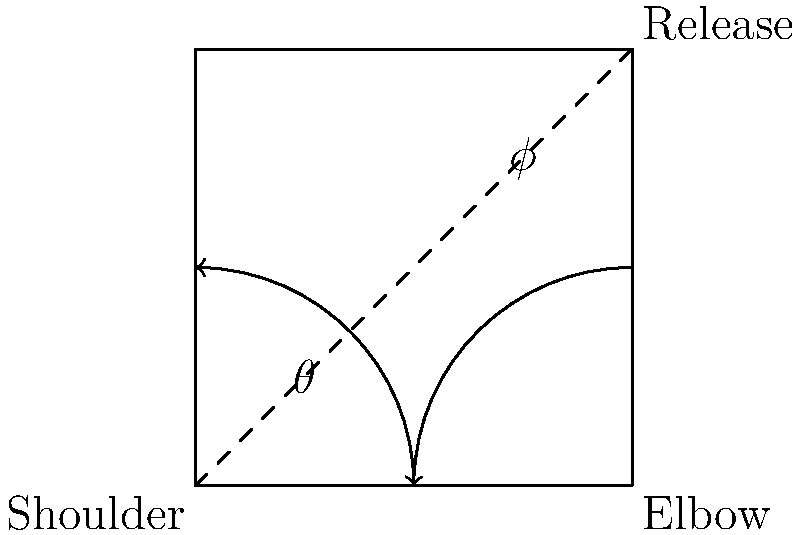In a quarterback's throwing motion, the angle between the upper arm and torso is represented by $\theta$, while the angle between the forearm and upper arm is represented by $\phi$. If $\theta = 45°$ and $\phi = 135°$, what is the total angular displacement of the arm from the starting position to the release point? To solve this problem, we need to follow these steps:

1. Understand the angles:
   - $\theta$ represents the angle between the upper arm and torso
   - $\phi$ represents the angle between the forearm and upper arm

2. Recognize that the total angular displacement is the sum of these two angles:
   Total angular displacement = $\theta + \phi$

3. Substitute the given values:
   Total angular displacement = $45° + 135°$

4. Perform the addition:
   Total angular displacement = $180°$

5. Interpret the result:
   The arm has rotated through a total of 180°, which is equivalent to a straight line or half a full rotation.

This angle is significant in football biomechanics as it represents the full extension of the arm at the point of release, which is crucial for maximizing the velocity and accuracy of the throw.
Answer: $180°$ 